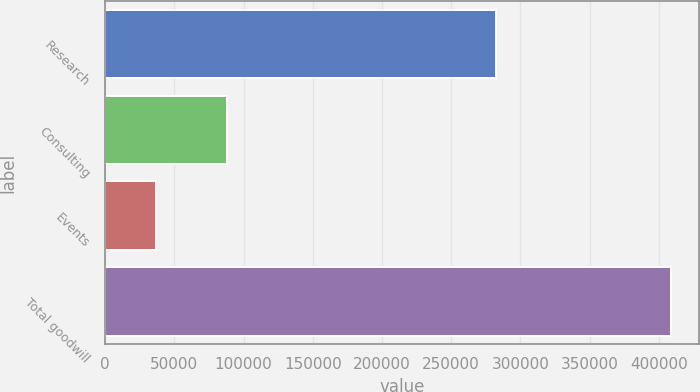<chart> <loc_0><loc_0><loc_500><loc_500><bar_chart><fcel>Research<fcel>Consulting<fcel>Events<fcel>Total goodwill<nl><fcel>282467<fcel>87666<fcel>36330<fcel>408545<nl></chart> 